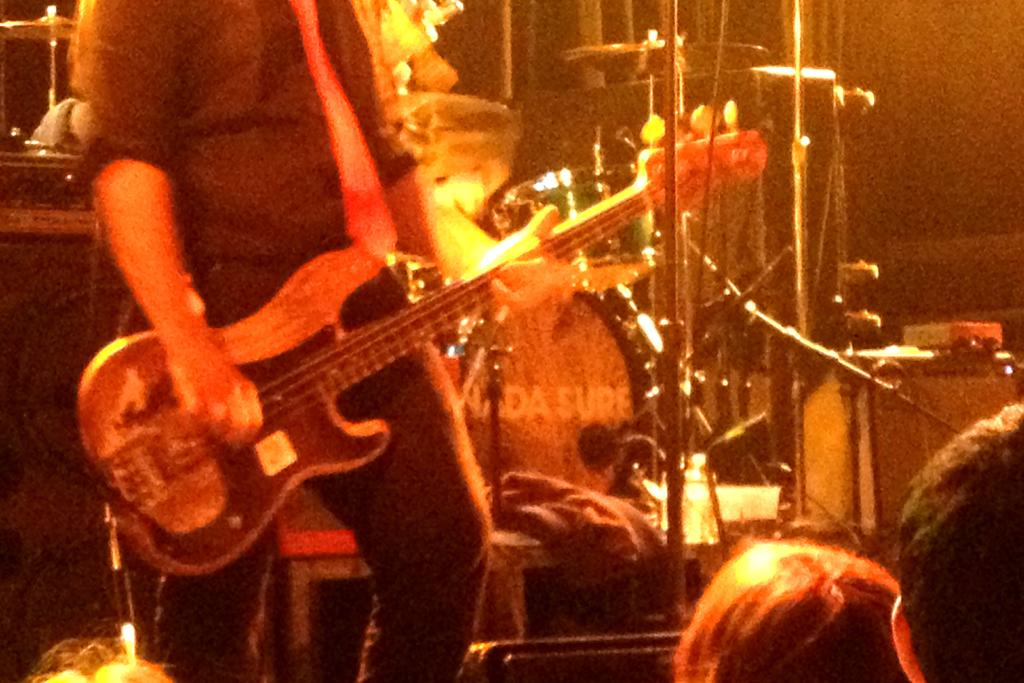What is the person in the image doing? The person is holding a guitar. What might the person be about to do with the guitar? The person might be about to play the guitar. What else can be seen in the image besides the person and the guitar? There are musical instruments visible in the background of the image. What type of tooth can be seen in the image? There is no tooth present in the image. How many eyes are visible in the image? There is no reference to eyes in the image, as it features a person holding a guitar and musical instruments in the background. 